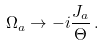Convert formula to latex. <formula><loc_0><loc_0><loc_500><loc_500>\Omega _ { a } \to - i \frac { J _ { a } } { \Theta } \, .</formula> 